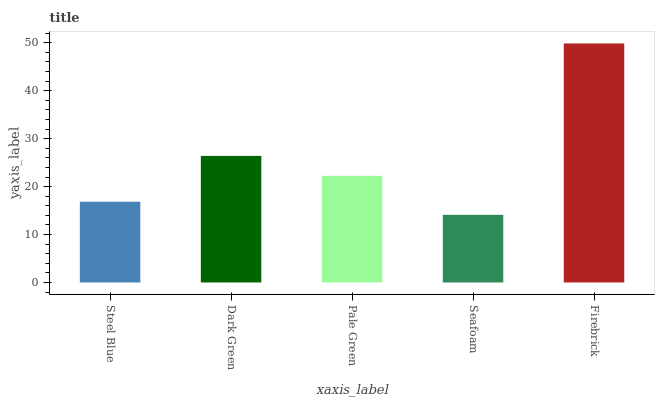Is Seafoam the minimum?
Answer yes or no. Yes. Is Firebrick the maximum?
Answer yes or no. Yes. Is Dark Green the minimum?
Answer yes or no. No. Is Dark Green the maximum?
Answer yes or no. No. Is Dark Green greater than Steel Blue?
Answer yes or no. Yes. Is Steel Blue less than Dark Green?
Answer yes or no. Yes. Is Steel Blue greater than Dark Green?
Answer yes or no. No. Is Dark Green less than Steel Blue?
Answer yes or no. No. Is Pale Green the high median?
Answer yes or no. Yes. Is Pale Green the low median?
Answer yes or no. Yes. Is Steel Blue the high median?
Answer yes or no. No. Is Firebrick the low median?
Answer yes or no. No. 